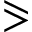Convert formula to latex. <formula><loc_0><loc_0><loc_500><loc_500>\ e q s l a n t g t r</formula> 